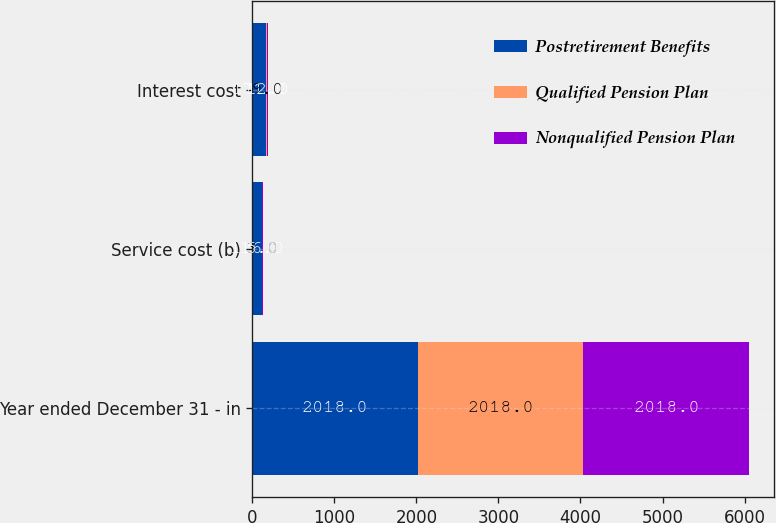<chart> <loc_0><loc_0><loc_500><loc_500><stacked_bar_chart><ecel><fcel>Year ended December 31 - in<fcel>Service cost (b)<fcel>Interest cost<nl><fcel>Postretirement Benefits<fcel>2018<fcel>116<fcel>171<nl><fcel>Qualified Pension Plan<fcel>2018<fcel>3<fcel>9<nl><fcel>Nonqualified Pension Plan<fcel>2018<fcel>5<fcel>12<nl></chart> 